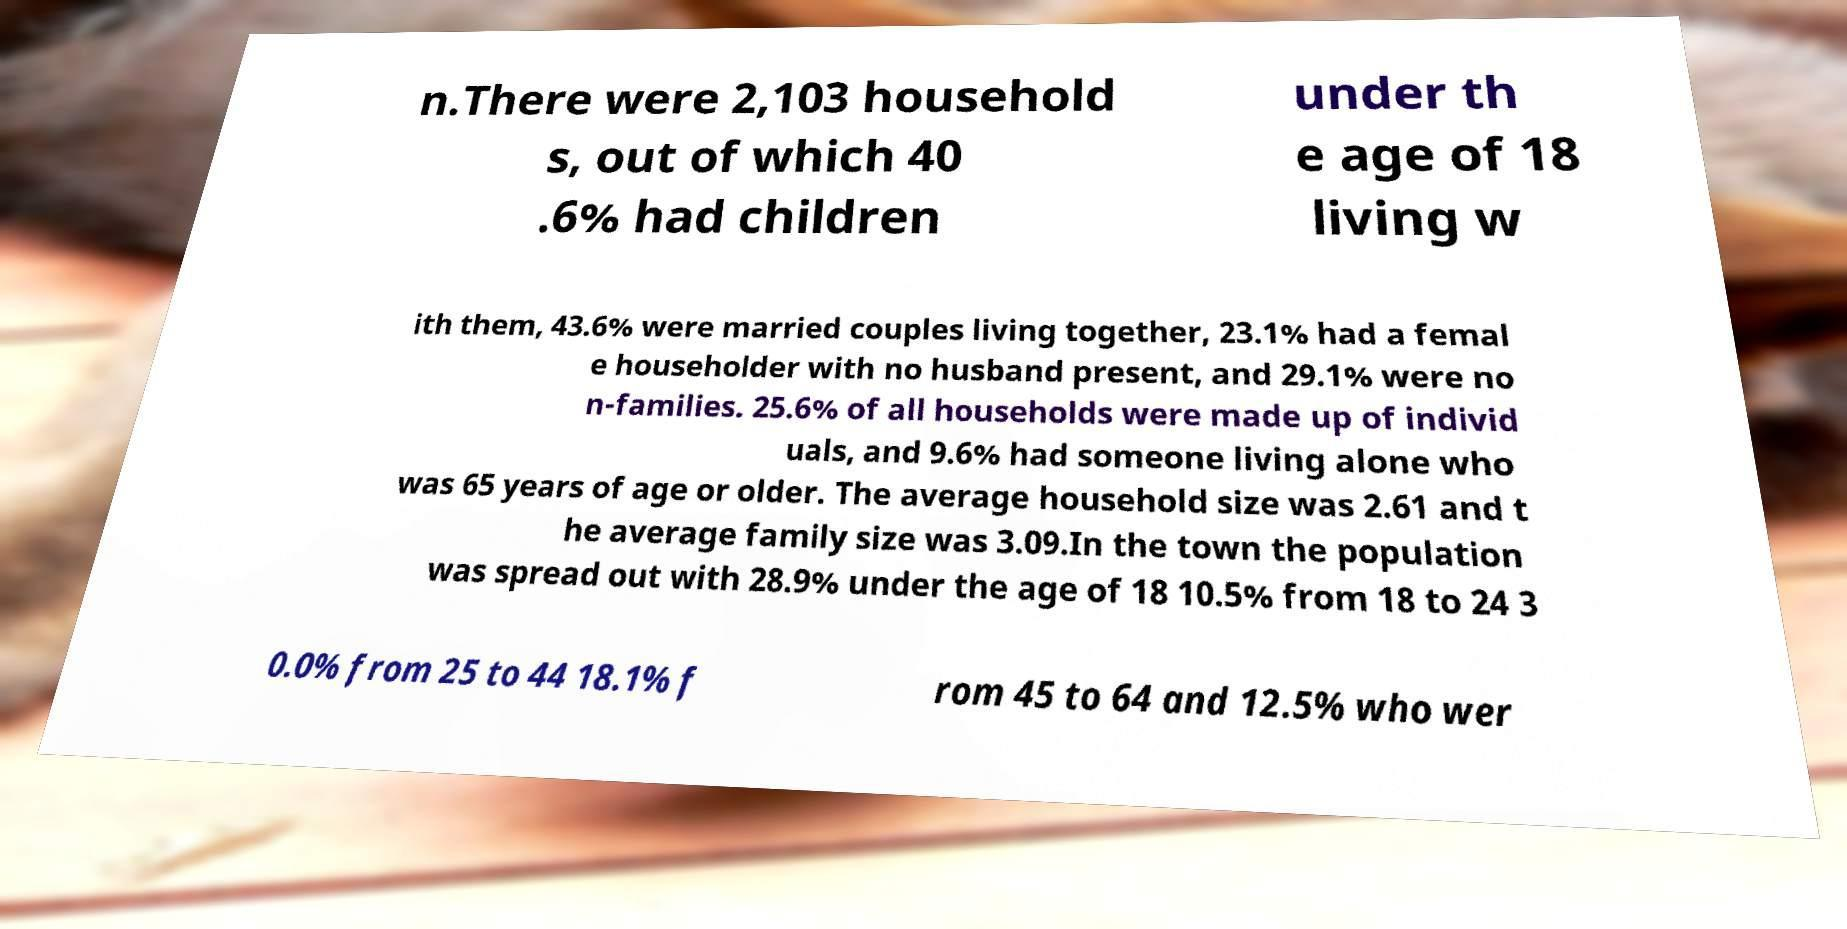Could you assist in decoding the text presented in this image and type it out clearly? n.There were 2,103 household s, out of which 40 .6% had children under th e age of 18 living w ith them, 43.6% were married couples living together, 23.1% had a femal e householder with no husband present, and 29.1% were no n-families. 25.6% of all households were made up of individ uals, and 9.6% had someone living alone who was 65 years of age or older. The average household size was 2.61 and t he average family size was 3.09.In the town the population was spread out with 28.9% under the age of 18 10.5% from 18 to 24 3 0.0% from 25 to 44 18.1% f rom 45 to 64 and 12.5% who wer 